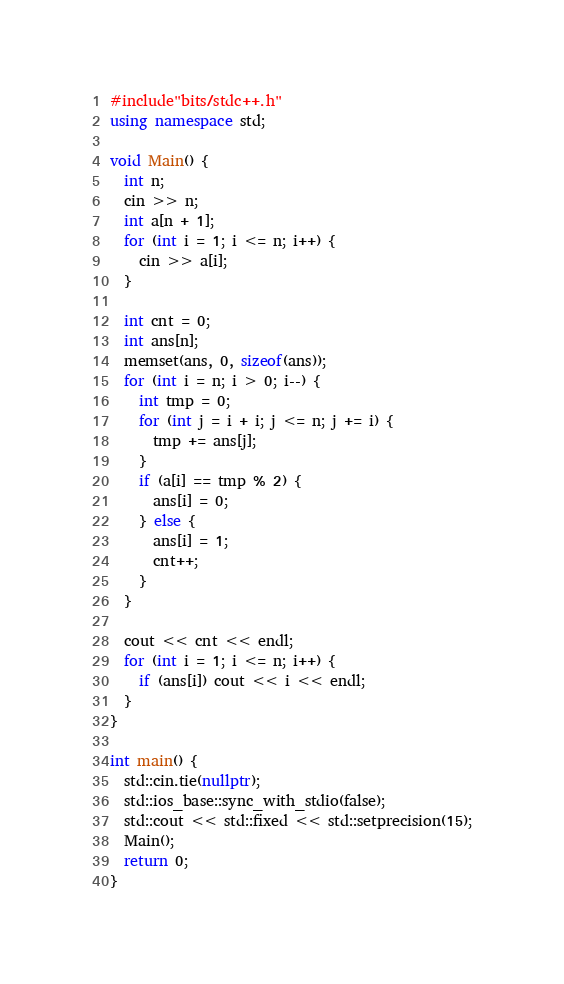<code> <loc_0><loc_0><loc_500><loc_500><_C++_>#include"bits/stdc++.h"
using namespace std;

void Main() {
  int n;
  cin >> n;
  int a[n + 1];
  for (int i = 1; i <= n; i++) {
    cin >> a[i];
  }

  int cnt = 0;
  int ans[n];
  memset(ans, 0, sizeof(ans));
  for (int i = n; i > 0; i--) {
    int tmp = 0;
    for (int j = i + i; j <= n; j += i) {
      tmp += ans[j];
    }
    if (a[i] == tmp % 2) {
      ans[i] = 0;
    } else {
      ans[i] = 1;
      cnt++;
    }
  }

  cout << cnt << endl;
  for (int i = 1; i <= n; i++) {
    if (ans[i]) cout << i << endl;
  }
}

int main() {
  std::cin.tie(nullptr);
  std::ios_base::sync_with_stdio(false);
  std::cout << std::fixed << std::setprecision(15);
  Main();
  return 0;
}</code> 